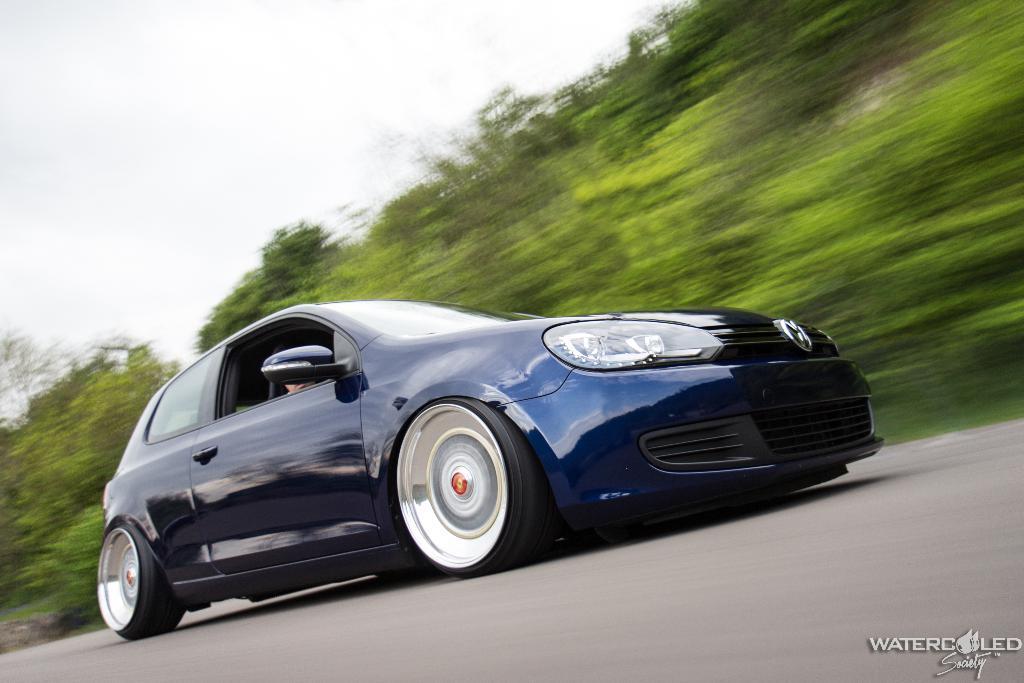Could you give a brief overview of what you see in this image? In this image there is a car moving on a road, in the background there are trees and the sky and it is blurred, in the bottom right there is text. 